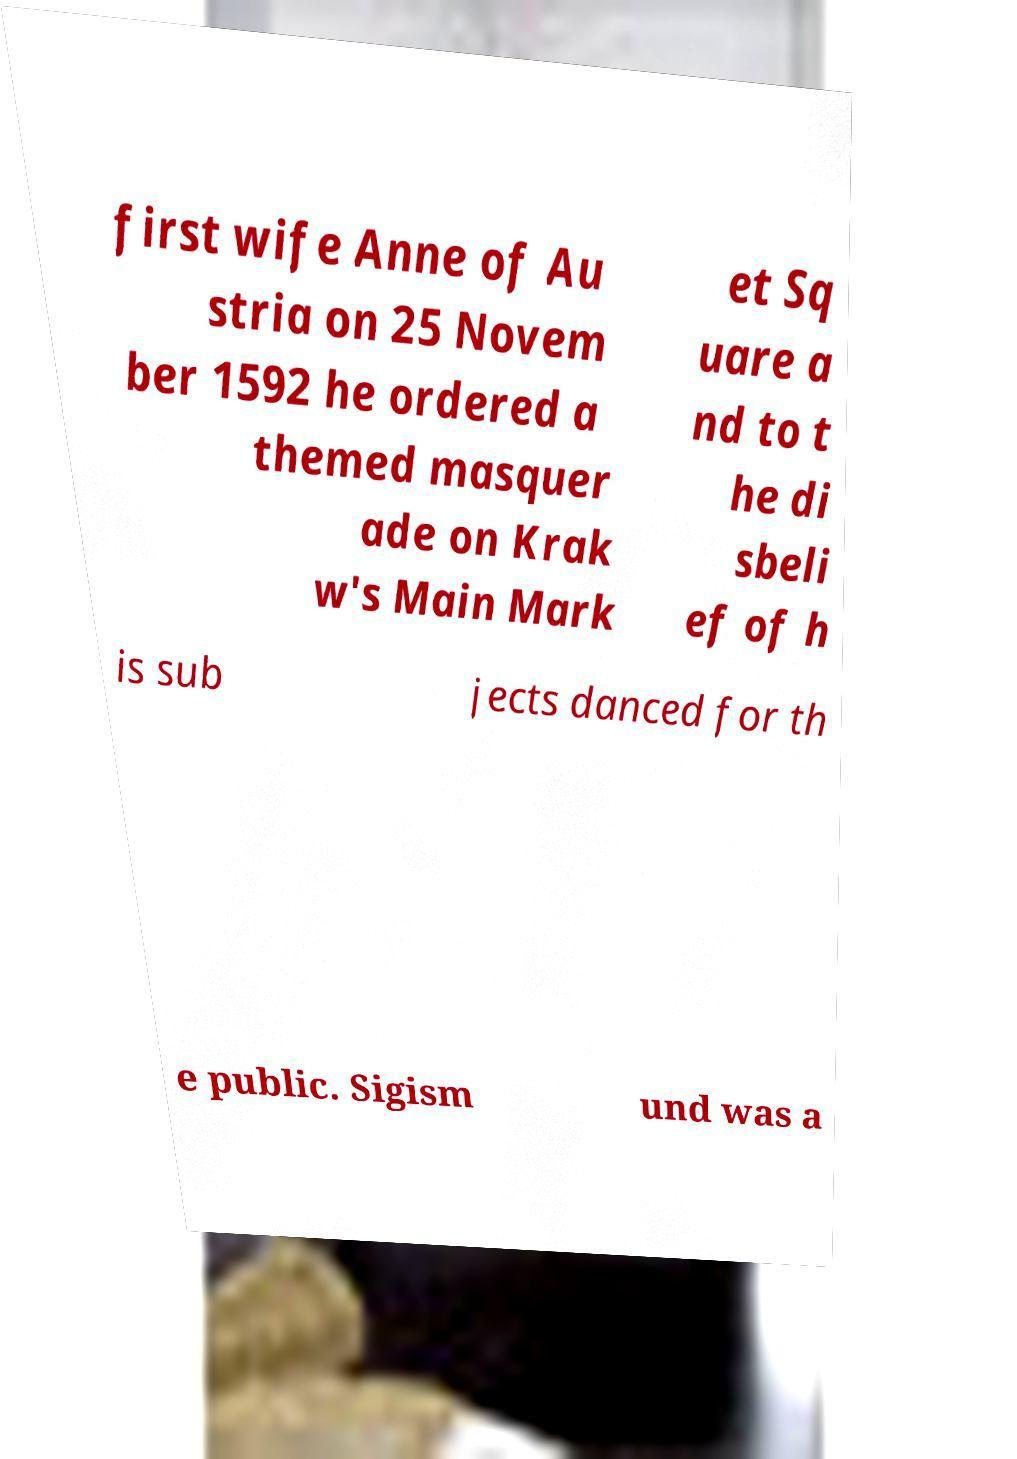For documentation purposes, I need the text within this image transcribed. Could you provide that? first wife Anne of Au stria on 25 Novem ber 1592 he ordered a themed masquer ade on Krak w's Main Mark et Sq uare a nd to t he di sbeli ef of h is sub jects danced for th e public. Sigism und was a 